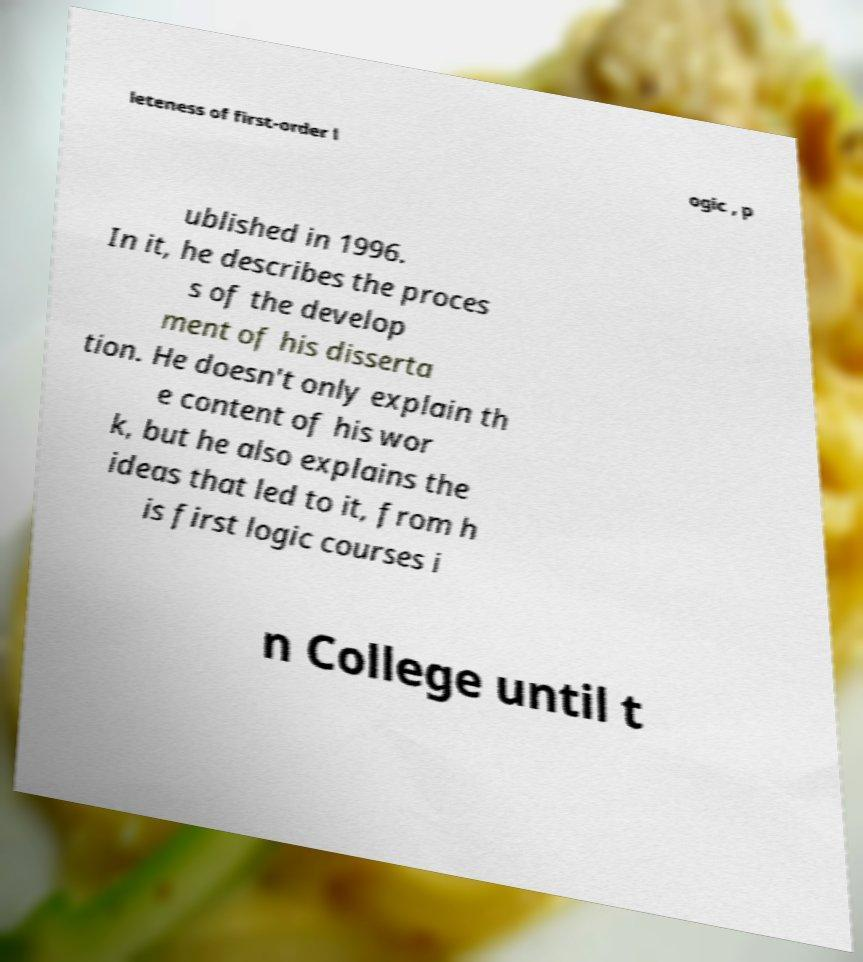There's text embedded in this image that I need extracted. Can you transcribe it verbatim? leteness of first-order l ogic , p ublished in 1996. In it, he describes the proces s of the develop ment of his disserta tion. He doesn't only explain th e content of his wor k, but he also explains the ideas that led to it, from h is first logic courses i n College until t 